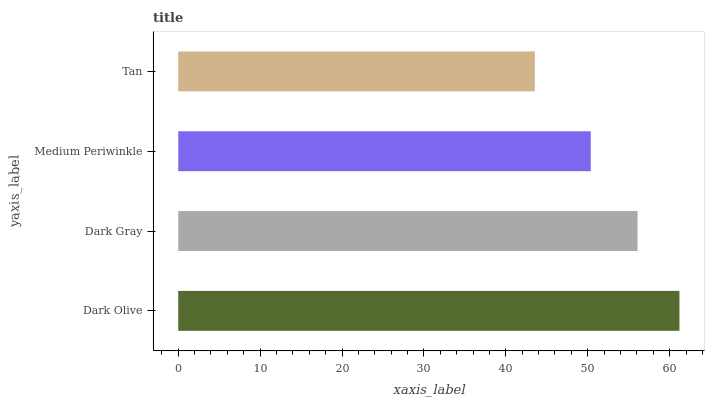Is Tan the minimum?
Answer yes or no. Yes. Is Dark Olive the maximum?
Answer yes or no. Yes. Is Dark Gray the minimum?
Answer yes or no. No. Is Dark Gray the maximum?
Answer yes or no. No. Is Dark Olive greater than Dark Gray?
Answer yes or no. Yes. Is Dark Gray less than Dark Olive?
Answer yes or no. Yes. Is Dark Gray greater than Dark Olive?
Answer yes or no. No. Is Dark Olive less than Dark Gray?
Answer yes or no. No. Is Dark Gray the high median?
Answer yes or no. Yes. Is Medium Periwinkle the low median?
Answer yes or no. Yes. Is Medium Periwinkle the high median?
Answer yes or no. No. Is Dark Olive the low median?
Answer yes or no. No. 